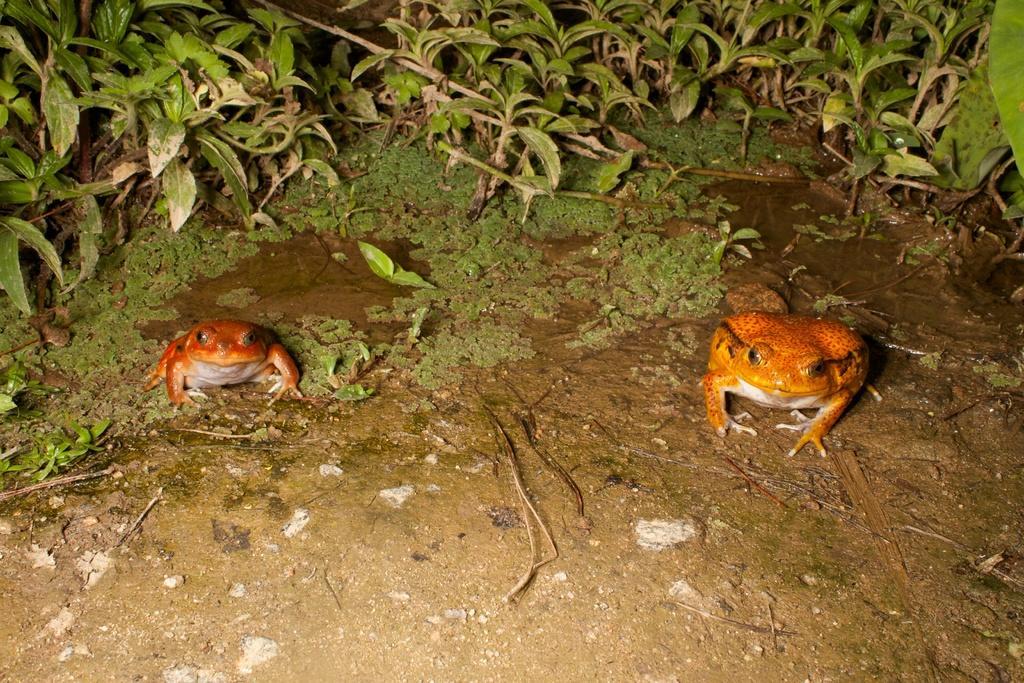Can you describe this image briefly? Here we can see two frogs, water, plants and algae in the image. 